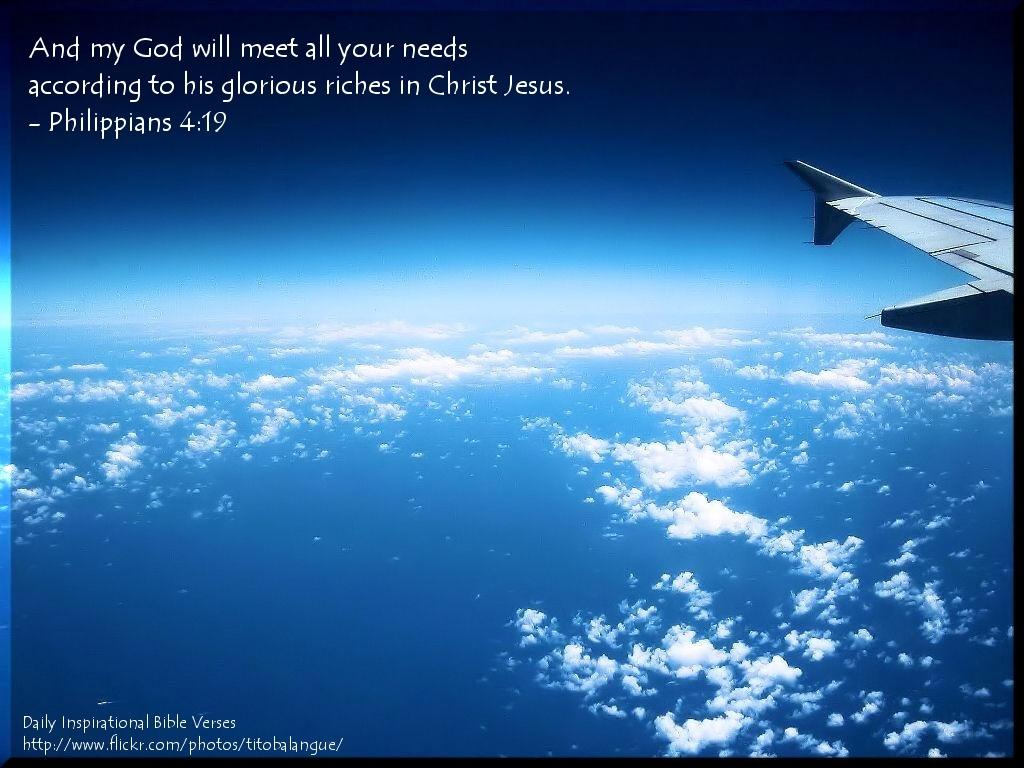<image>
Write a terse but informative summary of the picture. A picture of the Earth with the quote "And my God will meet all your needs according to his glorious riches in Christ." 